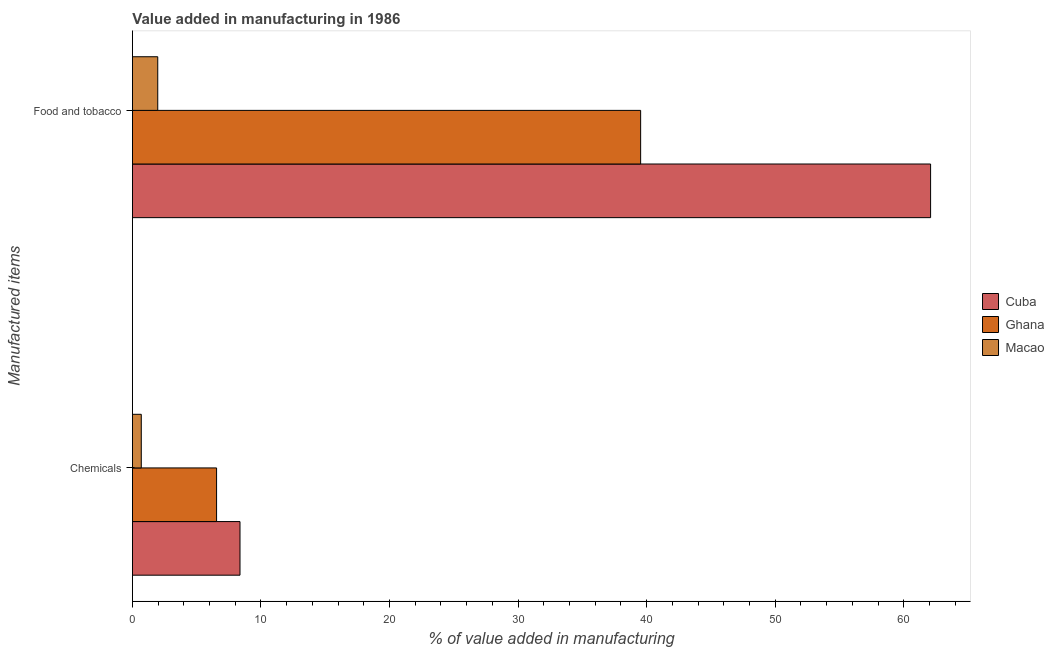How many different coloured bars are there?
Provide a succinct answer. 3. How many groups of bars are there?
Keep it short and to the point. 2. Are the number of bars on each tick of the Y-axis equal?
Your answer should be very brief. Yes. What is the label of the 1st group of bars from the top?
Your answer should be compact. Food and tobacco. What is the value added by manufacturing food and tobacco in Macao?
Your answer should be compact. 1.97. Across all countries, what is the maximum value added by manufacturing food and tobacco?
Provide a short and direct response. 62.09. Across all countries, what is the minimum value added by manufacturing food and tobacco?
Your answer should be compact. 1.97. In which country was the value added by  manufacturing chemicals maximum?
Ensure brevity in your answer.  Cuba. In which country was the value added by  manufacturing chemicals minimum?
Your response must be concise. Macao. What is the total value added by manufacturing food and tobacco in the graph?
Offer a terse response. 103.59. What is the difference between the value added by manufacturing food and tobacco in Ghana and that in Cuba?
Keep it short and to the point. -22.56. What is the difference between the value added by  manufacturing chemicals in Ghana and the value added by manufacturing food and tobacco in Macao?
Provide a succinct answer. 4.58. What is the average value added by  manufacturing chemicals per country?
Your answer should be compact. 5.2. What is the difference between the value added by manufacturing food and tobacco and value added by  manufacturing chemicals in Ghana?
Provide a short and direct response. 32.99. What is the ratio of the value added by manufacturing food and tobacco in Cuba to that in Ghana?
Your answer should be compact. 1.57. Is the value added by  manufacturing chemicals in Ghana less than that in Cuba?
Provide a succinct answer. Yes. In how many countries, is the value added by manufacturing food and tobacco greater than the average value added by manufacturing food and tobacco taken over all countries?
Give a very brief answer. 2. What does the 3rd bar from the bottom in Food and tobacco represents?
Your answer should be very brief. Macao. How many bars are there?
Provide a short and direct response. 6. How many countries are there in the graph?
Keep it short and to the point. 3. How many legend labels are there?
Keep it short and to the point. 3. What is the title of the graph?
Ensure brevity in your answer.  Value added in manufacturing in 1986. What is the label or title of the X-axis?
Make the answer very short. % of value added in manufacturing. What is the label or title of the Y-axis?
Offer a terse response. Manufactured items. What is the % of value added in manufacturing in Cuba in Chemicals?
Make the answer very short. 8.37. What is the % of value added in manufacturing of Ghana in Chemicals?
Make the answer very short. 6.55. What is the % of value added in manufacturing in Macao in Chemicals?
Provide a succinct answer. 0.69. What is the % of value added in manufacturing of Cuba in Food and tobacco?
Your response must be concise. 62.09. What is the % of value added in manufacturing in Ghana in Food and tobacco?
Give a very brief answer. 39.53. What is the % of value added in manufacturing of Macao in Food and tobacco?
Give a very brief answer. 1.97. Across all Manufactured items, what is the maximum % of value added in manufacturing in Cuba?
Your answer should be compact. 62.09. Across all Manufactured items, what is the maximum % of value added in manufacturing of Ghana?
Ensure brevity in your answer.  39.53. Across all Manufactured items, what is the maximum % of value added in manufacturing in Macao?
Ensure brevity in your answer.  1.97. Across all Manufactured items, what is the minimum % of value added in manufacturing of Cuba?
Ensure brevity in your answer.  8.37. Across all Manufactured items, what is the minimum % of value added in manufacturing of Ghana?
Offer a very short reply. 6.55. Across all Manufactured items, what is the minimum % of value added in manufacturing of Macao?
Keep it short and to the point. 0.69. What is the total % of value added in manufacturing in Cuba in the graph?
Your response must be concise. 70.46. What is the total % of value added in manufacturing in Ghana in the graph?
Provide a short and direct response. 46.08. What is the total % of value added in manufacturing of Macao in the graph?
Provide a succinct answer. 2.66. What is the difference between the % of value added in manufacturing in Cuba in Chemicals and that in Food and tobacco?
Give a very brief answer. -53.72. What is the difference between the % of value added in manufacturing of Ghana in Chemicals and that in Food and tobacco?
Provide a short and direct response. -32.99. What is the difference between the % of value added in manufacturing of Macao in Chemicals and that in Food and tobacco?
Ensure brevity in your answer.  -1.28. What is the difference between the % of value added in manufacturing of Cuba in Chemicals and the % of value added in manufacturing of Ghana in Food and tobacco?
Provide a short and direct response. -31.17. What is the difference between the % of value added in manufacturing in Cuba in Chemicals and the % of value added in manufacturing in Macao in Food and tobacco?
Your response must be concise. 6.4. What is the difference between the % of value added in manufacturing of Ghana in Chemicals and the % of value added in manufacturing of Macao in Food and tobacco?
Your response must be concise. 4.58. What is the average % of value added in manufacturing in Cuba per Manufactured items?
Ensure brevity in your answer.  35.23. What is the average % of value added in manufacturing of Ghana per Manufactured items?
Keep it short and to the point. 23.04. What is the average % of value added in manufacturing of Macao per Manufactured items?
Keep it short and to the point. 1.33. What is the difference between the % of value added in manufacturing of Cuba and % of value added in manufacturing of Ghana in Chemicals?
Provide a succinct answer. 1.82. What is the difference between the % of value added in manufacturing in Cuba and % of value added in manufacturing in Macao in Chemicals?
Your answer should be very brief. 7.68. What is the difference between the % of value added in manufacturing in Ghana and % of value added in manufacturing in Macao in Chemicals?
Your response must be concise. 5.86. What is the difference between the % of value added in manufacturing in Cuba and % of value added in manufacturing in Ghana in Food and tobacco?
Make the answer very short. 22.55. What is the difference between the % of value added in manufacturing in Cuba and % of value added in manufacturing in Macao in Food and tobacco?
Your answer should be very brief. 60.12. What is the difference between the % of value added in manufacturing of Ghana and % of value added in manufacturing of Macao in Food and tobacco?
Keep it short and to the point. 37.56. What is the ratio of the % of value added in manufacturing in Cuba in Chemicals to that in Food and tobacco?
Make the answer very short. 0.13. What is the ratio of the % of value added in manufacturing of Ghana in Chemicals to that in Food and tobacco?
Your answer should be very brief. 0.17. What is the ratio of the % of value added in manufacturing of Macao in Chemicals to that in Food and tobacco?
Offer a very short reply. 0.35. What is the difference between the highest and the second highest % of value added in manufacturing in Cuba?
Your response must be concise. 53.72. What is the difference between the highest and the second highest % of value added in manufacturing of Ghana?
Provide a short and direct response. 32.99. What is the difference between the highest and the second highest % of value added in manufacturing in Macao?
Offer a terse response. 1.28. What is the difference between the highest and the lowest % of value added in manufacturing in Cuba?
Keep it short and to the point. 53.72. What is the difference between the highest and the lowest % of value added in manufacturing of Ghana?
Give a very brief answer. 32.99. What is the difference between the highest and the lowest % of value added in manufacturing of Macao?
Your answer should be very brief. 1.28. 